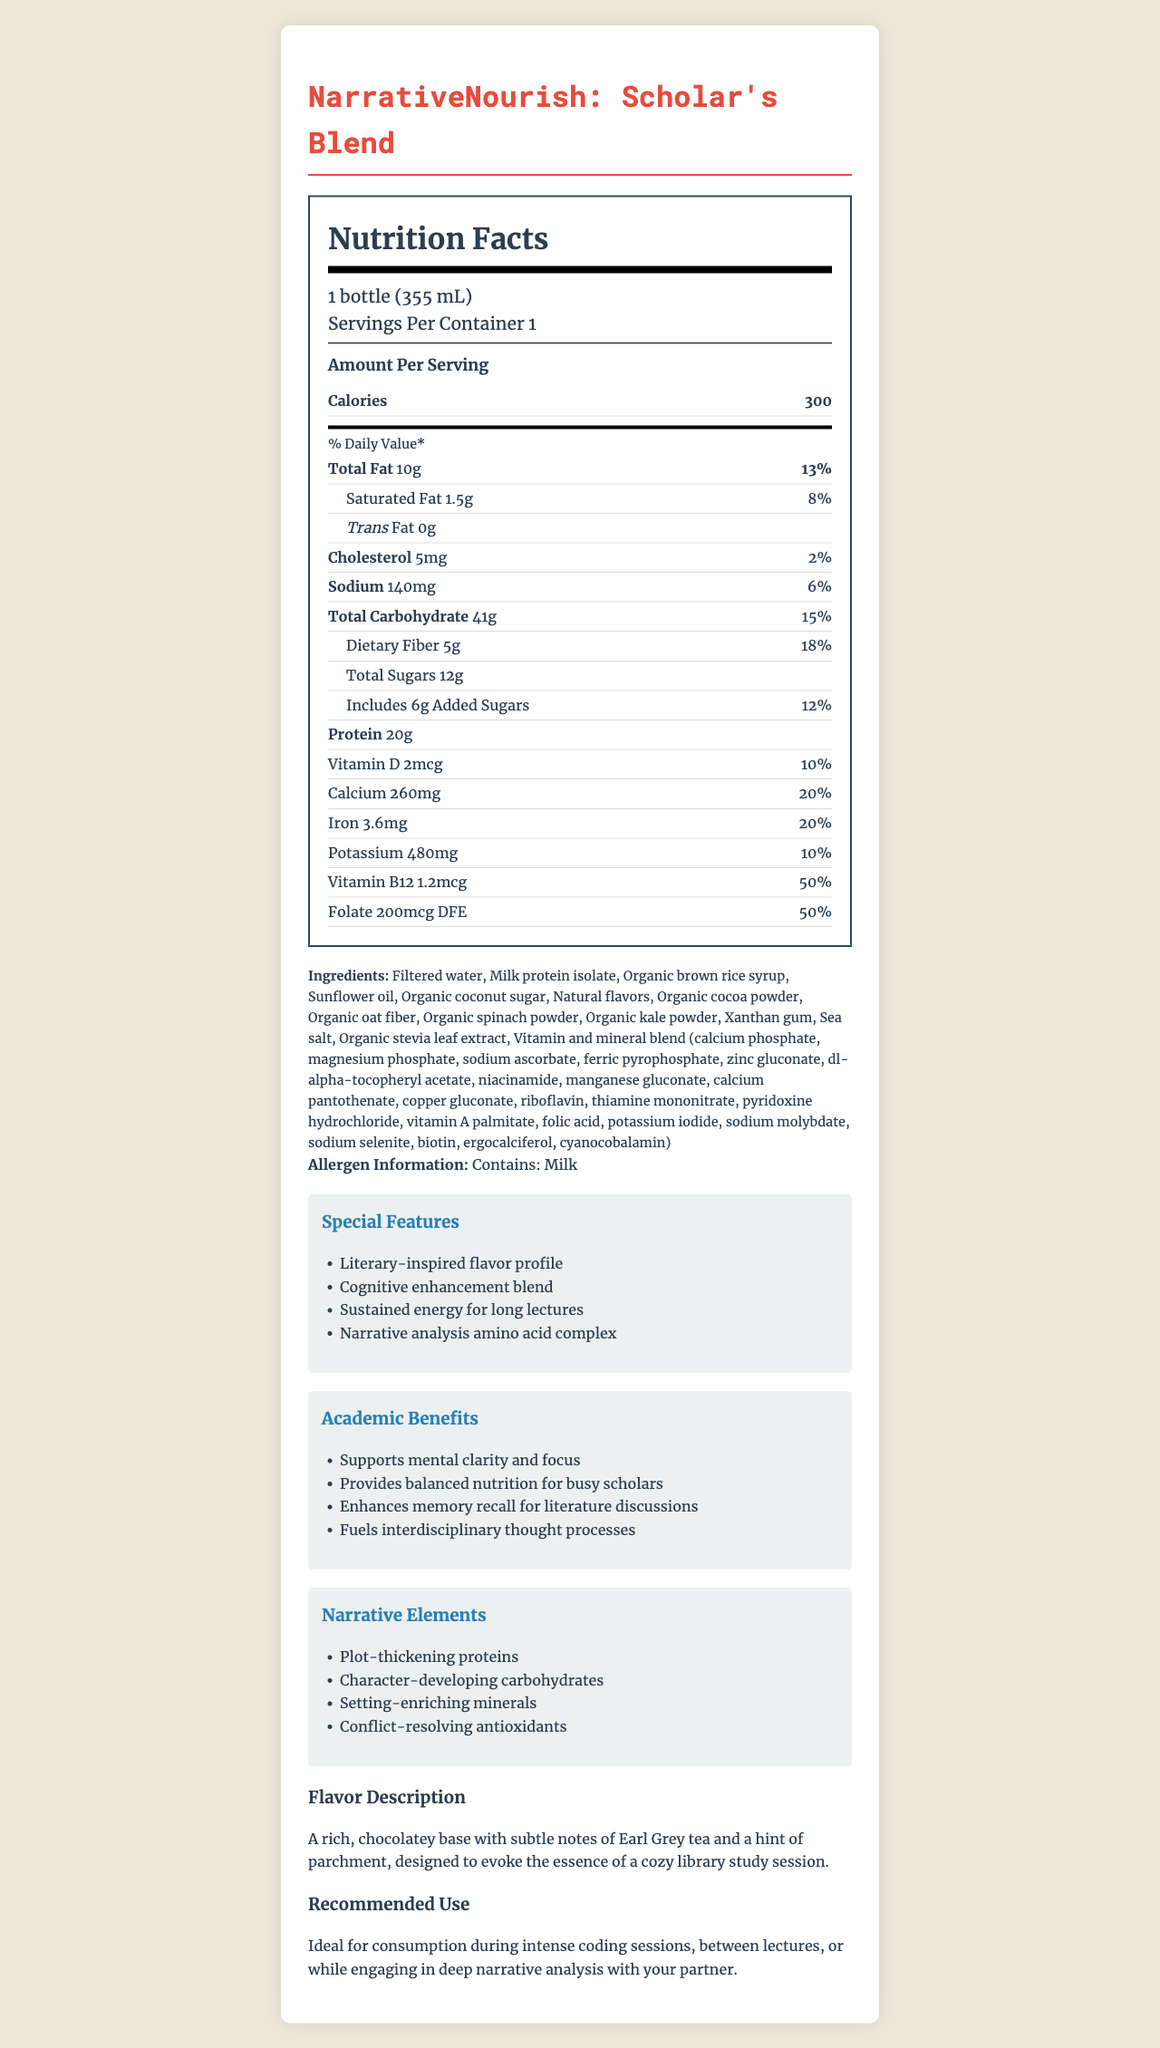what is the serving size of NarrativeNourish: Scholar's Blend? The serving size is specified as "1 bottle (355 mL)" under the serving information.
Answer: 1 bottle (355 mL) how much total fat does a serving contain? The document lists "Total Fat" as 10g under the nutrients section.
Answer: 10g how many grams of dietary fiber are in a serving? The dietary fiber content is mentioned as "5g" in the nutrient breakdown.
Answer: 5g What special feature suggests long-lasting energy for lectures? One of the special features listed is "Sustained energy for long lectures."
Answer: Sustained energy for long lectures which of the following nutrients has the highest daily value percentage? A. Vitamin D B. Calcium C. Folate D. Sodium Folate has a daily value percentage of 50%, which is the highest compared to others.
Answer: C how much potassium is in one serving? The nutrient section lists potassium content as 480mg.
Answer: 480mg Is the flavor of NarrativeNourish: Scholar's Blend chocolate-based? The flavor description mentions a "rich, chocolatey base."
Answer: Yes Does this product contain allergens? If so, which one? The allergen information clearly states "Contains: Milk."
Answer: Yes, Milk Summarize the nutritional content and special features of NarrativeNourish: Scholar's Blend. This summary captures both the nutritional content and special features as detailed in the document.
Answer: The NarrativeNourish: Scholar's Blend provides 300 calories per serving. It contains 10g of total fat, 41g of carbohydrates, and 20g of protein. Notable nutrients include 5g dietary fiber, 12g total sugars (6g added sugars), and a variety of vitamins and minerals. Special features include a literary-inspired flavor profile, cognitive enhancement blend, sustained energy for long lectures, and a narrative analysis amino acid complex. The flavor is a rich chocolate base with subtle notes of Earl Grey tea and parchment. It supports mental clarity and memory recall, ideal for busy academics. what is the percentage of the daily value for sodium? The daily value percentage for sodium is listed as 6%.
Answer: 6% which of the following is NOT an ingredient in the NarrativeNourish: Scholar's Blend? A. Sea salt B. Organic coconut sugar C. Cane sugar D. Organic cocoa powder Cane sugar is not listed; the ingredients include sea salt, organic coconut sugar, and organic cocoa powder.
Answer: C What is the main academic benefit of the shake related to literature discussions? The academic benefits section explicitly states "Enhances memory recall for literature discussions."
Answer: Enhances memory recall For what kind of activities is the NarrativeNourish: Scholar's Blend recommended? The recommended use section states it is ideal for these activities.
Answer: Intense coding sessions, between lectures, or while engaging in deep narrative analysis with your partner. Can the exact amount of iron in milligrams be determined? The iron content is explicitly listed as 3.6mg in the nutrition facts.
Answer: Yes What other language translations are available for the NarrativeNourish: Scholar's Blend document? The provided document does not include information about any language translations available.
Answer: Not enough information 